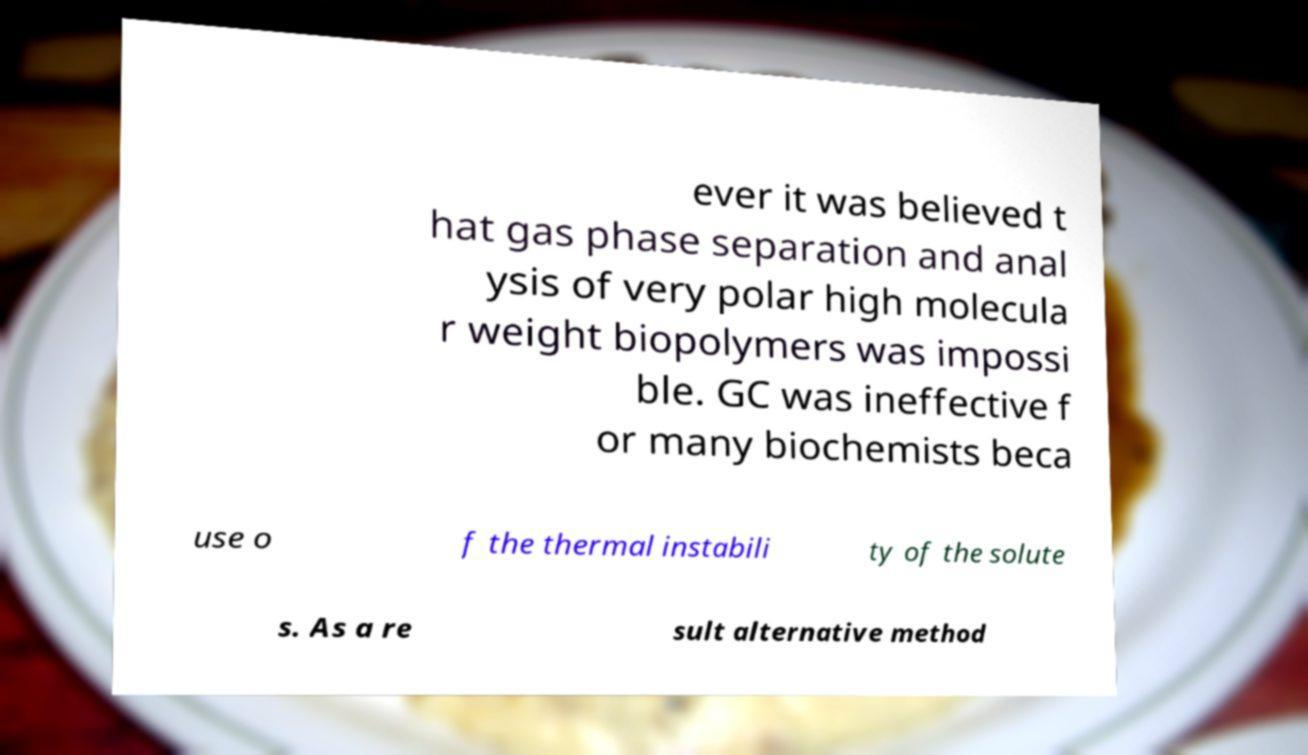Could you extract and type out the text from this image? ever it was believed t hat gas phase separation and anal ysis of very polar high molecula r weight biopolymers was impossi ble. GC was ineffective f or many biochemists beca use o f the thermal instabili ty of the solute s. As a re sult alternative method 